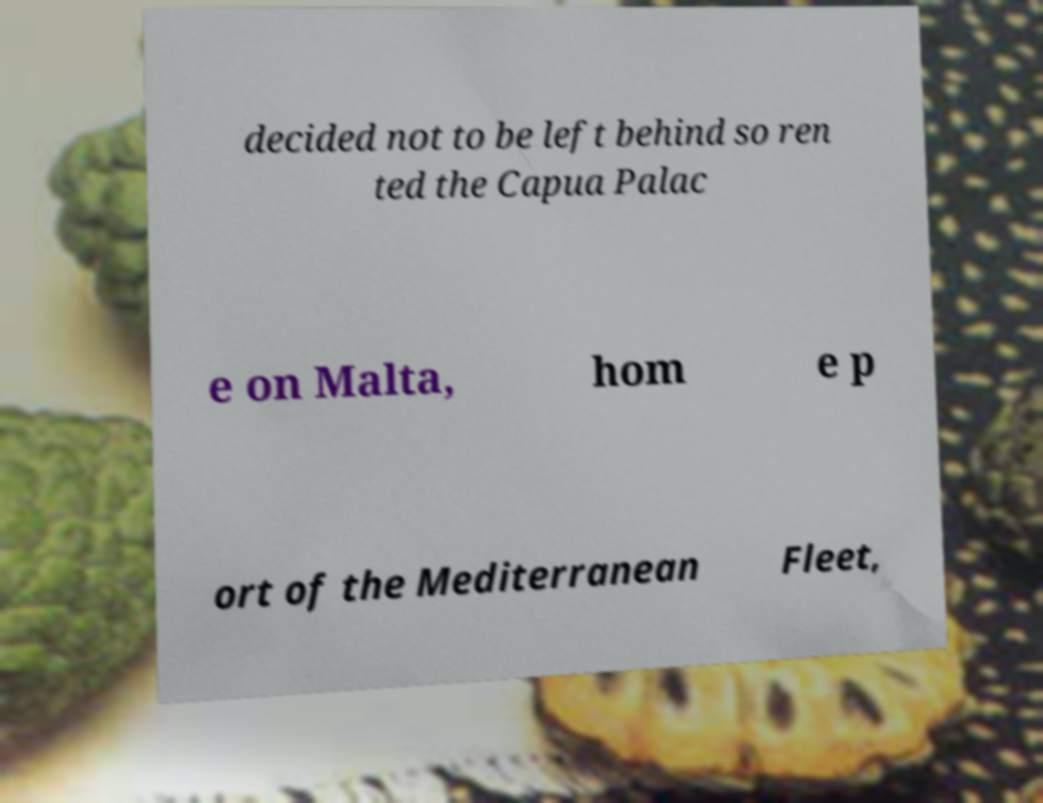What messages or text are displayed in this image? I need them in a readable, typed format. decided not to be left behind so ren ted the Capua Palac e on Malta, hom e p ort of the Mediterranean Fleet, 